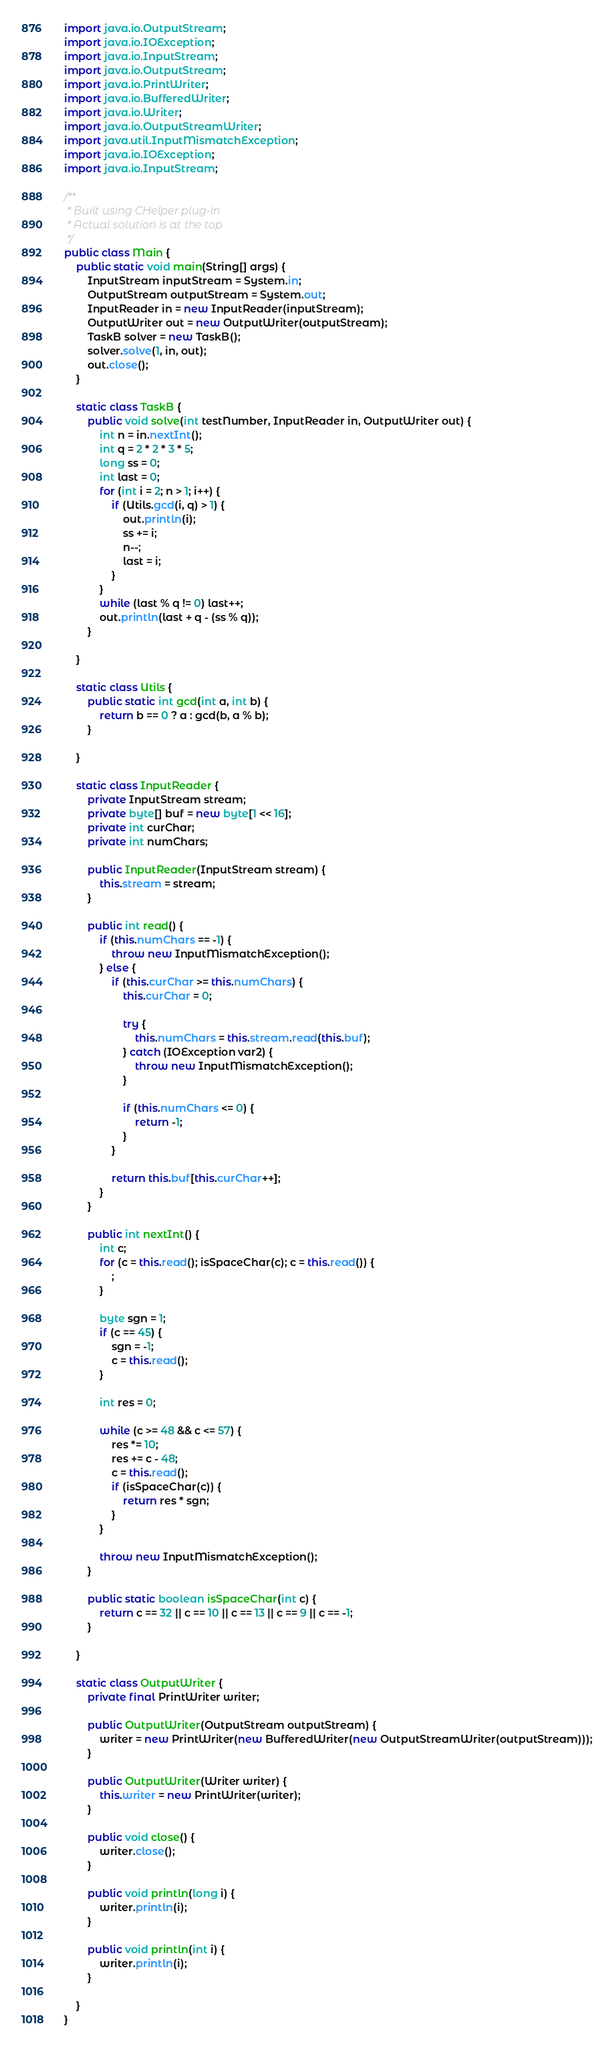Convert code to text. <code><loc_0><loc_0><loc_500><loc_500><_Java_>import java.io.OutputStream;
import java.io.IOException;
import java.io.InputStream;
import java.io.OutputStream;
import java.io.PrintWriter;
import java.io.BufferedWriter;
import java.io.Writer;
import java.io.OutputStreamWriter;
import java.util.InputMismatchException;
import java.io.IOException;
import java.io.InputStream;

/**
 * Built using CHelper plug-in
 * Actual solution is at the top
 */
public class Main {
    public static void main(String[] args) {
        InputStream inputStream = System.in;
        OutputStream outputStream = System.out;
        InputReader in = new InputReader(inputStream);
        OutputWriter out = new OutputWriter(outputStream);
        TaskB solver = new TaskB();
        solver.solve(1, in, out);
        out.close();
    }

    static class TaskB {
        public void solve(int testNumber, InputReader in, OutputWriter out) {
            int n = in.nextInt();
            int q = 2 * 2 * 3 * 5;
            long ss = 0;
            int last = 0;
            for (int i = 2; n > 1; i++) {
                if (Utils.gcd(i, q) > 1) {
                    out.println(i);
                    ss += i;
                    n--;
                    last = i;
                }
            }
            while (last % q != 0) last++;
            out.println(last + q - (ss % q));
        }

    }

    static class Utils {
        public static int gcd(int a, int b) {
            return b == 0 ? a : gcd(b, a % b);
        }

    }

    static class InputReader {
        private InputStream stream;
        private byte[] buf = new byte[1 << 16];
        private int curChar;
        private int numChars;

        public InputReader(InputStream stream) {
            this.stream = stream;
        }

        public int read() {
            if (this.numChars == -1) {
                throw new InputMismatchException();
            } else {
                if (this.curChar >= this.numChars) {
                    this.curChar = 0;

                    try {
                        this.numChars = this.stream.read(this.buf);
                    } catch (IOException var2) {
                        throw new InputMismatchException();
                    }

                    if (this.numChars <= 0) {
                        return -1;
                    }
                }

                return this.buf[this.curChar++];
            }
        }

        public int nextInt() {
            int c;
            for (c = this.read(); isSpaceChar(c); c = this.read()) {
                ;
            }

            byte sgn = 1;
            if (c == 45) {
                sgn = -1;
                c = this.read();
            }

            int res = 0;

            while (c >= 48 && c <= 57) {
                res *= 10;
                res += c - 48;
                c = this.read();
                if (isSpaceChar(c)) {
                    return res * sgn;
                }
            }

            throw new InputMismatchException();
        }

        public static boolean isSpaceChar(int c) {
            return c == 32 || c == 10 || c == 13 || c == 9 || c == -1;
        }

    }

    static class OutputWriter {
        private final PrintWriter writer;

        public OutputWriter(OutputStream outputStream) {
            writer = new PrintWriter(new BufferedWriter(new OutputStreamWriter(outputStream)));
        }

        public OutputWriter(Writer writer) {
            this.writer = new PrintWriter(writer);
        }

        public void close() {
            writer.close();
        }

        public void println(long i) {
            writer.println(i);
        }

        public void println(int i) {
            writer.println(i);
        }

    }
}

</code> 